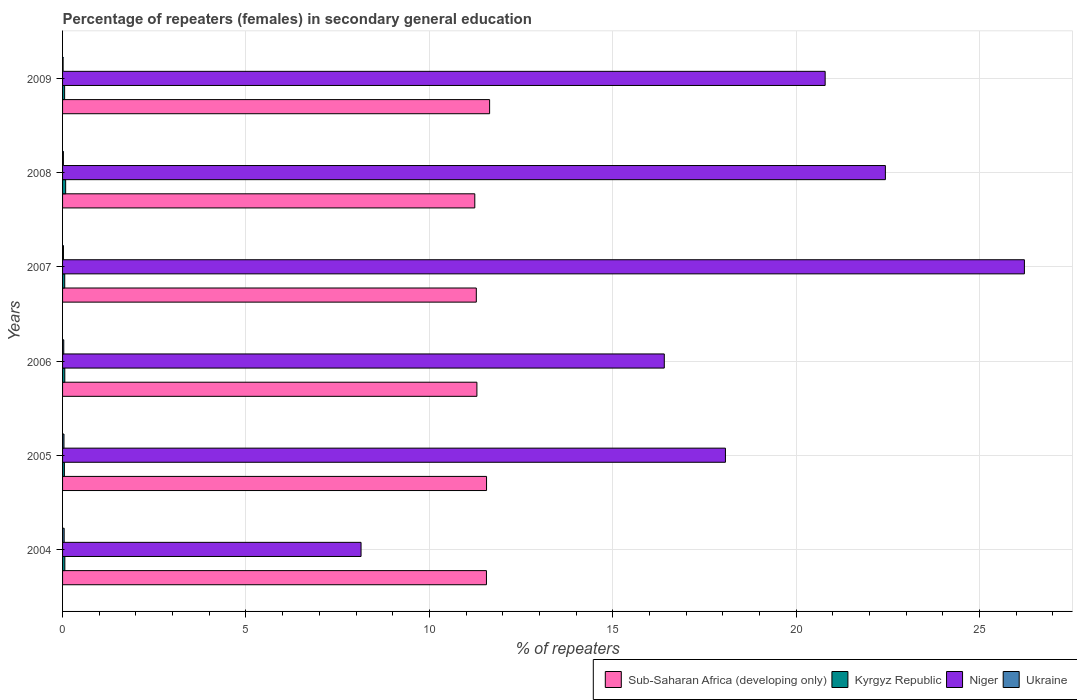How many different coloured bars are there?
Ensure brevity in your answer.  4. Are the number of bars per tick equal to the number of legend labels?
Offer a very short reply. Yes. Are the number of bars on each tick of the Y-axis equal?
Provide a short and direct response. Yes. What is the label of the 2nd group of bars from the top?
Your answer should be very brief. 2008. In how many cases, is the number of bars for a given year not equal to the number of legend labels?
Provide a short and direct response. 0. What is the percentage of female repeaters in Niger in 2004?
Offer a terse response. 8.14. Across all years, what is the maximum percentage of female repeaters in Niger?
Make the answer very short. 26.22. Across all years, what is the minimum percentage of female repeaters in Niger?
Offer a very short reply. 8.14. In which year was the percentage of female repeaters in Niger maximum?
Provide a short and direct response. 2007. What is the total percentage of female repeaters in Sub-Saharan Africa (developing only) in the graph?
Offer a terse response. 68.57. What is the difference between the percentage of female repeaters in Niger in 2004 and that in 2007?
Give a very brief answer. -18.09. What is the difference between the percentage of female repeaters in Niger in 2009 and the percentage of female repeaters in Ukraine in 2007?
Your answer should be very brief. 20.77. What is the average percentage of female repeaters in Sub-Saharan Africa (developing only) per year?
Ensure brevity in your answer.  11.43. In the year 2007, what is the difference between the percentage of female repeaters in Niger and percentage of female repeaters in Sub-Saharan Africa (developing only)?
Make the answer very short. 14.94. In how many years, is the percentage of female repeaters in Kyrgyz Republic greater than 14 %?
Your response must be concise. 0. What is the ratio of the percentage of female repeaters in Ukraine in 2005 to that in 2009?
Keep it short and to the point. 2.65. Is the difference between the percentage of female repeaters in Niger in 2007 and 2008 greater than the difference between the percentage of female repeaters in Sub-Saharan Africa (developing only) in 2007 and 2008?
Provide a succinct answer. Yes. What is the difference between the highest and the second highest percentage of female repeaters in Kyrgyz Republic?
Provide a succinct answer. 0.02. What is the difference between the highest and the lowest percentage of female repeaters in Sub-Saharan Africa (developing only)?
Your response must be concise. 0.4. Is the sum of the percentage of female repeaters in Niger in 2007 and 2009 greater than the maximum percentage of female repeaters in Sub-Saharan Africa (developing only) across all years?
Ensure brevity in your answer.  Yes. What does the 1st bar from the top in 2007 represents?
Keep it short and to the point. Ukraine. What does the 3rd bar from the bottom in 2007 represents?
Offer a terse response. Niger. Is it the case that in every year, the sum of the percentage of female repeaters in Niger and percentage of female repeaters in Sub-Saharan Africa (developing only) is greater than the percentage of female repeaters in Kyrgyz Republic?
Your response must be concise. Yes. Does the graph contain grids?
Ensure brevity in your answer.  Yes. Where does the legend appear in the graph?
Your response must be concise. Bottom right. What is the title of the graph?
Provide a succinct answer. Percentage of repeaters (females) in secondary general education. Does "Dominican Republic" appear as one of the legend labels in the graph?
Make the answer very short. No. What is the label or title of the X-axis?
Offer a very short reply. % of repeaters. What is the % of repeaters of Sub-Saharan Africa (developing only) in 2004?
Offer a terse response. 11.56. What is the % of repeaters of Kyrgyz Republic in 2004?
Your answer should be compact. 0.06. What is the % of repeaters of Niger in 2004?
Provide a succinct answer. 8.14. What is the % of repeaters in Ukraine in 2004?
Ensure brevity in your answer.  0.04. What is the % of repeaters in Sub-Saharan Africa (developing only) in 2005?
Give a very brief answer. 11.56. What is the % of repeaters of Kyrgyz Republic in 2005?
Your answer should be very brief. 0.05. What is the % of repeaters in Niger in 2005?
Make the answer very short. 18.07. What is the % of repeaters in Ukraine in 2005?
Keep it short and to the point. 0.04. What is the % of repeaters of Sub-Saharan Africa (developing only) in 2006?
Provide a succinct answer. 11.3. What is the % of repeaters of Kyrgyz Republic in 2006?
Keep it short and to the point. 0.06. What is the % of repeaters in Niger in 2006?
Give a very brief answer. 16.41. What is the % of repeaters in Ukraine in 2006?
Provide a short and direct response. 0.03. What is the % of repeaters of Sub-Saharan Africa (developing only) in 2007?
Keep it short and to the point. 11.28. What is the % of repeaters of Kyrgyz Republic in 2007?
Your response must be concise. 0.06. What is the % of repeaters in Niger in 2007?
Make the answer very short. 26.22. What is the % of repeaters of Ukraine in 2007?
Your answer should be compact. 0.02. What is the % of repeaters of Sub-Saharan Africa (developing only) in 2008?
Keep it short and to the point. 11.24. What is the % of repeaters in Kyrgyz Republic in 2008?
Offer a very short reply. 0.08. What is the % of repeaters of Niger in 2008?
Your answer should be compact. 22.43. What is the % of repeaters of Ukraine in 2008?
Keep it short and to the point. 0.02. What is the % of repeaters in Sub-Saharan Africa (developing only) in 2009?
Offer a very short reply. 11.64. What is the % of repeaters in Kyrgyz Republic in 2009?
Ensure brevity in your answer.  0.06. What is the % of repeaters of Niger in 2009?
Offer a terse response. 20.79. What is the % of repeaters of Ukraine in 2009?
Make the answer very short. 0.01. Across all years, what is the maximum % of repeaters of Sub-Saharan Africa (developing only)?
Give a very brief answer. 11.64. Across all years, what is the maximum % of repeaters in Kyrgyz Republic?
Provide a short and direct response. 0.08. Across all years, what is the maximum % of repeaters of Niger?
Your answer should be very brief. 26.22. Across all years, what is the maximum % of repeaters in Ukraine?
Keep it short and to the point. 0.04. Across all years, what is the minimum % of repeaters in Sub-Saharan Africa (developing only)?
Provide a succinct answer. 11.24. Across all years, what is the minimum % of repeaters in Kyrgyz Republic?
Make the answer very short. 0.05. Across all years, what is the minimum % of repeaters in Niger?
Keep it short and to the point. 8.14. Across all years, what is the minimum % of repeaters of Ukraine?
Make the answer very short. 0.01. What is the total % of repeaters of Sub-Saharan Africa (developing only) in the graph?
Ensure brevity in your answer.  68.57. What is the total % of repeaters of Kyrgyz Republic in the graph?
Make the answer very short. 0.37. What is the total % of repeaters of Niger in the graph?
Your answer should be very brief. 112.06. What is the total % of repeaters in Ukraine in the graph?
Keep it short and to the point. 0.18. What is the difference between the % of repeaters of Sub-Saharan Africa (developing only) in 2004 and that in 2005?
Your answer should be compact. -0. What is the difference between the % of repeaters in Kyrgyz Republic in 2004 and that in 2005?
Provide a short and direct response. 0.01. What is the difference between the % of repeaters of Niger in 2004 and that in 2005?
Provide a succinct answer. -9.93. What is the difference between the % of repeaters of Ukraine in 2004 and that in 2005?
Keep it short and to the point. 0. What is the difference between the % of repeaters of Sub-Saharan Africa (developing only) in 2004 and that in 2006?
Provide a succinct answer. 0.26. What is the difference between the % of repeaters in Kyrgyz Republic in 2004 and that in 2006?
Ensure brevity in your answer.  0. What is the difference between the % of repeaters of Niger in 2004 and that in 2006?
Keep it short and to the point. -8.27. What is the difference between the % of repeaters of Ukraine in 2004 and that in 2006?
Offer a very short reply. 0.01. What is the difference between the % of repeaters of Sub-Saharan Africa (developing only) in 2004 and that in 2007?
Provide a short and direct response. 0.28. What is the difference between the % of repeaters of Kyrgyz Republic in 2004 and that in 2007?
Your answer should be compact. 0. What is the difference between the % of repeaters in Niger in 2004 and that in 2007?
Provide a short and direct response. -18.09. What is the difference between the % of repeaters in Ukraine in 2004 and that in 2007?
Offer a very short reply. 0.02. What is the difference between the % of repeaters in Sub-Saharan Africa (developing only) in 2004 and that in 2008?
Your answer should be very brief. 0.32. What is the difference between the % of repeaters of Kyrgyz Republic in 2004 and that in 2008?
Your answer should be compact. -0.02. What is the difference between the % of repeaters in Niger in 2004 and that in 2008?
Your answer should be compact. -14.3. What is the difference between the % of repeaters of Ukraine in 2004 and that in 2008?
Offer a terse response. 0.02. What is the difference between the % of repeaters in Sub-Saharan Africa (developing only) in 2004 and that in 2009?
Provide a succinct answer. -0.09. What is the difference between the % of repeaters in Kyrgyz Republic in 2004 and that in 2009?
Your response must be concise. 0.01. What is the difference between the % of repeaters of Niger in 2004 and that in 2009?
Ensure brevity in your answer.  -12.65. What is the difference between the % of repeaters in Ukraine in 2004 and that in 2009?
Provide a short and direct response. 0.03. What is the difference between the % of repeaters of Sub-Saharan Africa (developing only) in 2005 and that in 2006?
Ensure brevity in your answer.  0.26. What is the difference between the % of repeaters in Kyrgyz Republic in 2005 and that in 2006?
Your response must be concise. -0.01. What is the difference between the % of repeaters of Niger in 2005 and that in 2006?
Keep it short and to the point. 1.67. What is the difference between the % of repeaters of Ukraine in 2005 and that in 2006?
Your response must be concise. 0.01. What is the difference between the % of repeaters in Sub-Saharan Africa (developing only) in 2005 and that in 2007?
Give a very brief answer. 0.28. What is the difference between the % of repeaters of Kyrgyz Republic in 2005 and that in 2007?
Offer a very short reply. -0.01. What is the difference between the % of repeaters in Niger in 2005 and that in 2007?
Your answer should be very brief. -8.15. What is the difference between the % of repeaters of Ukraine in 2005 and that in 2007?
Give a very brief answer. 0.01. What is the difference between the % of repeaters in Sub-Saharan Africa (developing only) in 2005 and that in 2008?
Offer a very short reply. 0.32. What is the difference between the % of repeaters of Kyrgyz Republic in 2005 and that in 2008?
Offer a terse response. -0.03. What is the difference between the % of repeaters of Niger in 2005 and that in 2008?
Your answer should be compact. -4.36. What is the difference between the % of repeaters of Ukraine in 2005 and that in 2008?
Your answer should be very brief. 0.02. What is the difference between the % of repeaters of Sub-Saharan Africa (developing only) in 2005 and that in 2009?
Offer a very short reply. -0.08. What is the difference between the % of repeaters in Kyrgyz Republic in 2005 and that in 2009?
Your answer should be very brief. -0.01. What is the difference between the % of repeaters in Niger in 2005 and that in 2009?
Your answer should be compact. -2.72. What is the difference between the % of repeaters in Ukraine in 2005 and that in 2009?
Ensure brevity in your answer.  0.02. What is the difference between the % of repeaters of Sub-Saharan Africa (developing only) in 2006 and that in 2007?
Ensure brevity in your answer.  0.02. What is the difference between the % of repeaters of Kyrgyz Republic in 2006 and that in 2007?
Offer a terse response. 0. What is the difference between the % of repeaters of Niger in 2006 and that in 2007?
Make the answer very short. -9.82. What is the difference between the % of repeaters of Ukraine in 2006 and that in 2007?
Provide a succinct answer. 0.01. What is the difference between the % of repeaters of Sub-Saharan Africa (developing only) in 2006 and that in 2008?
Your answer should be very brief. 0.06. What is the difference between the % of repeaters in Kyrgyz Republic in 2006 and that in 2008?
Provide a succinct answer. -0.02. What is the difference between the % of repeaters in Niger in 2006 and that in 2008?
Your response must be concise. -6.03. What is the difference between the % of repeaters of Ukraine in 2006 and that in 2008?
Offer a terse response. 0.01. What is the difference between the % of repeaters in Sub-Saharan Africa (developing only) in 2006 and that in 2009?
Offer a terse response. -0.35. What is the difference between the % of repeaters in Kyrgyz Republic in 2006 and that in 2009?
Your answer should be compact. 0. What is the difference between the % of repeaters in Niger in 2006 and that in 2009?
Provide a short and direct response. -4.39. What is the difference between the % of repeaters in Ukraine in 2006 and that in 2009?
Provide a succinct answer. 0.02. What is the difference between the % of repeaters of Sub-Saharan Africa (developing only) in 2007 and that in 2008?
Provide a succinct answer. 0.04. What is the difference between the % of repeaters in Kyrgyz Republic in 2007 and that in 2008?
Offer a very short reply. -0.03. What is the difference between the % of repeaters of Niger in 2007 and that in 2008?
Offer a terse response. 3.79. What is the difference between the % of repeaters of Ukraine in 2007 and that in 2008?
Offer a very short reply. 0. What is the difference between the % of repeaters in Sub-Saharan Africa (developing only) in 2007 and that in 2009?
Offer a very short reply. -0.36. What is the difference between the % of repeaters in Kyrgyz Republic in 2007 and that in 2009?
Provide a succinct answer. 0. What is the difference between the % of repeaters in Niger in 2007 and that in 2009?
Give a very brief answer. 5.43. What is the difference between the % of repeaters of Ukraine in 2007 and that in 2009?
Offer a terse response. 0.01. What is the difference between the % of repeaters of Sub-Saharan Africa (developing only) in 2008 and that in 2009?
Offer a very short reply. -0.4. What is the difference between the % of repeaters in Kyrgyz Republic in 2008 and that in 2009?
Make the answer very short. 0.03. What is the difference between the % of repeaters of Niger in 2008 and that in 2009?
Offer a very short reply. 1.64. What is the difference between the % of repeaters of Ukraine in 2008 and that in 2009?
Your response must be concise. 0.01. What is the difference between the % of repeaters in Sub-Saharan Africa (developing only) in 2004 and the % of repeaters in Kyrgyz Republic in 2005?
Provide a short and direct response. 11.51. What is the difference between the % of repeaters in Sub-Saharan Africa (developing only) in 2004 and the % of repeaters in Niger in 2005?
Your answer should be compact. -6.52. What is the difference between the % of repeaters in Sub-Saharan Africa (developing only) in 2004 and the % of repeaters in Ukraine in 2005?
Ensure brevity in your answer.  11.52. What is the difference between the % of repeaters in Kyrgyz Republic in 2004 and the % of repeaters in Niger in 2005?
Provide a short and direct response. -18.01. What is the difference between the % of repeaters of Kyrgyz Republic in 2004 and the % of repeaters of Ukraine in 2005?
Provide a succinct answer. 0.02. What is the difference between the % of repeaters in Niger in 2004 and the % of repeaters in Ukraine in 2005?
Provide a succinct answer. 8.1. What is the difference between the % of repeaters of Sub-Saharan Africa (developing only) in 2004 and the % of repeaters of Kyrgyz Republic in 2006?
Provide a succinct answer. 11.5. What is the difference between the % of repeaters in Sub-Saharan Africa (developing only) in 2004 and the % of repeaters in Niger in 2006?
Ensure brevity in your answer.  -4.85. What is the difference between the % of repeaters in Sub-Saharan Africa (developing only) in 2004 and the % of repeaters in Ukraine in 2006?
Give a very brief answer. 11.52. What is the difference between the % of repeaters of Kyrgyz Republic in 2004 and the % of repeaters of Niger in 2006?
Provide a succinct answer. -16.34. What is the difference between the % of repeaters in Kyrgyz Republic in 2004 and the % of repeaters in Ukraine in 2006?
Offer a terse response. 0.03. What is the difference between the % of repeaters in Niger in 2004 and the % of repeaters in Ukraine in 2006?
Make the answer very short. 8.1. What is the difference between the % of repeaters in Sub-Saharan Africa (developing only) in 2004 and the % of repeaters in Kyrgyz Republic in 2007?
Give a very brief answer. 11.5. What is the difference between the % of repeaters of Sub-Saharan Africa (developing only) in 2004 and the % of repeaters of Niger in 2007?
Provide a short and direct response. -14.67. What is the difference between the % of repeaters of Sub-Saharan Africa (developing only) in 2004 and the % of repeaters of Ukraine in 2007?
Keep it short and to the point. 11.53. What is the difference between the % of repeaters in Kyrgyz Republic in 2004 and the % of repeaters in Niger in 2007?
Offer a very short reply. -26.16. What is the difference between the % of repeaters of Kyrgyz Republic in 2004 and the % of repeaters of Ukraine in 2007?
Your response must be concise. 0.04. What is the difference between the % of repeaters of Niger in 2004 and the % of repeaters of Ukraine in 2007?
Your answer should be very brief. 8.11. What is the difference between the % of repeaters in Sub-Saharan Africa (developing only) in 2004 and the % of repeaters in Kyrgyz Republic in 2008?
Your response must be concise. 11.47. What is the difference between the % of repeaters of Sub-Saharan Africa (developing only) in 2004 and the % of repeaters of Niger in 2008?
Provide a succinct answer. -10.88. What is the difference between the % of repeaters of Sub-Saharan Africa (developing only) in 2004 and the % of repeaters of Ukraine in 2008?
Your response must be concise. 11.53. What is the difference between the % of repeaters of Kyrgyz Republic in 2004 and the % of repeaters of Niger in 2008?
Your answer should be very brief. -22.37. What is the difference between the % of repeaters in Kyrgyz Republic in 2004 and the % of repeaters in Ukraine in 2008?
Your response must be concise. 0.04. What is the difference between the % of repeaters of Niger in 2004 and the % of repeaters of Ukraine in 2008?
Ensure brevity in your answer.  8.11. What is the difference between the % of repeaters in Sub-Saharan Africa (developing only) in 2004 and the % of repeaters in Kyrgyz Republic in 2009?
Offer a terse response. 11.5. What is the difference between the % of repeaters of Sub-Saharan Africa (developing only) in 2004 and the % of repeaters of Niger in 2009?
Offer a terse response. -9.23. What is the difference between the % of repeaters in Sub-Saharan Africa (developing only) in 2004 and the % of repeaters in Ukraine in 2009?
Provide a succinct answer. 11.54. What is the difference between the % of repeaters of Kyrgyz Republic in 2004 and the % of repeaters of Niger in 2009?
Provide a succinct answer. -20.73. What is the difference between the % of repeaters of Kyrgyz Republic in 2004 and the % of repeaters of Ukraine in 2009?
Provide a succinct answer. 0.05. What is the difference between the % of repeaters in Niger in 2004 and the % of repeaters in Ukraine in 2009?
Keep it short and to the point. 8.12. What is the difference between the % of repeaters in Sub-Saharan Africa (developing only) in 2005 and the % of repeaters in Kyrgyz Republic in 2006?
Offer a terse response. 11.5. What is the difference between the % of repeaters of Sub-Saharan Africa (developing only) in 2005 and the % of repeaters of Niger in 2006?
Ensure brevity in your answer.  -4.85. What is the difference between the % of repeaters of Sub-Saharan Africa (developing only) in 2005 and the % of repeaters of Ukraine in 2006?
Give a very brief answer. 11.53. What is the difference between the % of repeaters in Kyrgyz Republic in 2005 and the % of repeaters in Niger in 2006?
Ensure brevity in your answer.  -16.36. What is the difference between the % of repeaters in Kyrgyz Republic in 2005 and the % of repeaters in Ukraine in 2006?
Offer a terse response. 0.02. What is the difference between the % of repeaters of Niger in 2005 and the % of repeaters of Ukraine in 2006?
Offer a terse response. 18.04. What is the difference between the % of repeaters in Sub-Saharan Africa (developing only) in 2005 and the % of repeaters in Kyrgyz Republic in 2007?
Give a very brief answer. 11.5. What is the difference between the % of repeaters in Sub-Saharan Africa (developing only) in 2005 and the % of repeaters in Niger in 2007?
Give a very brief answer. -14.66. What is the difference between the % of repeaters of Sub-Saharan Africa (developing only) in 2005 and the % of repeaters of Ukraine in 2007?
Provide a succinct answer. 11.54. What is the difference between the % of repeaters in Kyrgyz Republic in 2005 and the % of repeaters in Niger in 2007?
Offer a terse response. -26.17. What is the difference between the % of repeaters of Kyrgyz Republic in 2005 and the % of repeaters of Ukraine in 2007?
Make the answer very short. 0.03. What is the difference between the % of repeaters of Niger in 2005 and the % of repeaters of Ukraine in 2007?
Keep it short and to the point. 18.05. What is the difference between the % of repeaters of Sub-Saharan Africa (developing only) in 2005 and the % of repeaters of Kyrgyz Republic in 2008?
Provide a succinct answer. 11.47. What is the difference between the % of repeaters in Sub-Saharan Africa (developing only) in 2005 and the % of repeaters in Niger in 2008?
Your response must be concise. -10.87. What is the difference between the % of repeaters in Sub-Saharan Africa (developing only) in 2005 and the % of repeaters in Ukraine in 2008?
Your response must be concise. 11.54. What is the difference between the % of repeaters of Kyrgyz Republic in 2005 and the % of repeaters of Niger in 2008?
Make the answer very short. -22.38. What is the difference between the % of repeaters in Kyrgyz Republic in 2005 and the % of repeaters in Ukraine in 2008?
Your answer should be very brief. 0.03. What is the difference between the % of repeaters of Niger in 2005 and the % of repeaters of Ukraine in 2008?
Provide a succinct answer. 18.05. What is the difference between the % of repeaters of Sub-Saharan Africa (developing only) in 2005 and the % of repeaters of Kyrgyz Republic in 2009?
Provide a succinct answer. 11.5. What is the difference between the % of repeaters in Sub-Saharan Africa (developing only) in 2005 and the % of repeaters in Niger in 2009?
Keep it short and to the point. -9.23. What is the difference between the % of repeaters of Sub-Saharan Africa (developing only) in 2005 and the % of repeaters of Ukraine in 2009?
Offer a very short reply. 11.54. What is the difference between the % of repeaters of Kyrgyz Republic in 2005 and the % of repeaters of Niger in 2009?
Your answer should be very brief. -20.74. What is the difference between the % of repeaters of Kyrgyz Republic in 2005 and the % of repeaters of Ukraine in 2009?
Your answer should be compact. 0.04. What is the difference between the % of repeaters in Niger in 2005 and the % of repeaters in Ukraine in 2009?
Your answer should be compact. 18.06. What is the difference between the % of repeaters of Sub-Saharan Africa (developing only) in 2006 and the % of repeaters of Kyrgyz Republic in 2007?
Your answer should be compact. 11.24. What is the difference between the % of repeaters of Sub-Saharan Africa (developing only) in 2006 and the % of repeaters of Niger in 2007?
Offer a terse response. -14.93. What is the difference between the % of repeaters of Sub-Saharan Africa (developing only) in 2006 and the % of repeaters of Ukraine in 2007?
Offer a terse response. 11.27. What is the difference between the % of repeaters of Kyrgyz Republic in 2006 and the % of repeaters of Niger in 2007?
Provide a succinct answer. -26.16. What is the difference between the % of repeaters of Kyrgyz Republic in 2006 and the % of repeaters of Ukraine in 2007?
Ensure brevity in your answer.  0.04. What is the difference between the % of repeaters in Niger in 2006 and the % of repeaters in Ukraine in 2007?
Give a very brief answer. 16.38. What is the difference between the % of repeaters in Sub-Saharan Africa (developing only) in 2006 and the % of repeaters in Kyrgyz Republic in 2008?
Offer a terse response. 11.21. What is the difference between the % of repeaters in Sub-Saharan Africa (developing only) in 2006 and the % of repeaters in Niger in 2008?
Provide a succinct answer. -11.14. What is the difference between the % of repeaters of Sub-Saharan Africa (developing only) in 2006 and the % of repeaters of Ukraine in 2008?
Keep it short and to the point. 11.27. What is the difference between the % of repeaters in Kyrgyz Republic in 2006 and the % of repeaters in Niger in 2008?
Offer a very short reply. -22.37. What is the difference between the % of repeaters of Kyrgyz Republic in 2006 and the % of repeaters of Ukraine in 2008?
Provide a short and direct response. 0.04. What is the difference between the % of repeaters of Niger in 2006 and the % of repeaters of Ukraine in 2008?
Ensure brevity in your answer.  16.38. What is the difference between the % of repeaters in Sub-Saharan Africa (developing only) in 2006 and the % of repeaters in Kyrgyz Republic in 2009?
Your answer should be compact. 11.24. What is the difference between the % of repeaters of Sub-Saharan Africa (developing only) in 2006 and the % of repeaters of Niger in 2009?
Offer a terse response. -9.49. What is the difference between the % of repeaters in Sub-Saharan Africa (developing only) in 2006 and the % of repeaters in Ukraine in 2009?
Ensure brevity in your answer.  11.28. What is the difference between the % of repeaters in Kyrgyz Republic in 2006 and the % of repeaters in Niger in 2009?
Your response must be concise. -20.73. What is the difference between the % of repeaters in Kyrgyz Republic in 2006 and the % of repeaters in Ukraine in 2009?
Keep it short and to the point. 0.05. What is the difference between the % of repeaters of Niger in 2006 and the % of repeaters of Ukraine in 2009?
Offer a very short reply. 16.39. What is the difference between the % of repeaters of Sub-Saharan Africa (developing only) in 2007 and the % of repeaters of Kyrgyz Republic in 2008?
Ensure brevity in your answer.  11.2. What is the difference between the % of repeaters of Sub-Saharan Africa (developing only) in 2007 and the % of repeaters of Niger in 2008?
Offer a terse response. -11.15. What is the difference between the % of repeaters of Sub-Saharan Africa (developing only) in 2007 and the % of repeaters of Ukraine in 2008?
Make the answer very short. 11.26. What is the difference between the % of repeaters of Kyrgyz Republic in 2007 and the % of repeaters of Niger in 2008?
Give a very brief answer. -22.37. What is the difference between the % of repeaters in Kyrgyz Republic in 2007 and the % of repeaters in Ukraine in 2008?
Provide a succinct answer. 0.04. What is the difference between the % of repeaters in Niger in 2007 and the % of repeaters in Ukraine in 2008?
Offer a very short reply. 26.2. What is the difference between the % of repeaters in Sub-Saharan Africa (developing only) in 2007 and the % of repeaters in Kyrgyz Republic in 2009?
Ensure brevity in your answer.  11.22. What is the difference between the % of repeaters in Sub-Saharan Africa (developing only) in 2007 and the % of repeaters in Niger in 2009?
Your answer should be compact. -9.51. What is the difference between the % of repeaters in Sub-Saharan Africa (developing only) in 2007 and the % of repeaters in Ukraine in 2009?
Provide a short and direct response. 11.27. What is the difference between the % of repeaters in Kyrgyz Republic in 2007 and the % of repeaters in Niger in 2009?
Ensure brevity in your answer.  -20.73. What is the difference between the % of repeaters in Kyrgyz Republic in 2007 and the % of repeaters in Ukraine in 2009?
Your answer should be compact. 0.04. What is the difference between the % of repeaters in Niger in 2007 and the % of repeaters in Ukraine in 2009?
Keep it short and to the point. 26.21. What is the difference between the % of repeaters in Sub-Saharan Africa (developing only) in 2008 and the % of repeaters in Kyrgyz Republic in 2009?
Offer a very short reply. 11.18. What is the difference between the % of repeaters in Sub-Saharan Africa (developing only) in 2008 and the % of repeaters in Niger in 2009?
Offer a terse response. -9.55. What is the difference between the % of repeaters of Sub-Saharan Africa (developing only) in 2008 and the % of repeaters of Ukraine in 2009?
Give a very brief answer. 11.22. What is the difference between the % of repeaters in Kyrgyz Republic in 2008 and the % of repeaters in Niger in 2009?
Your answer should be compact. -20.71. What is the difference between the % of repeaters of Kyrgyz Republic in 2008 and the % of repeaters of Ukraine in 2009?
Offer a very short reply. 0.07. What is the difference between the % of repeaters of Niger in 2008 and the % of repeaters of Ukraine in 2009?
Provide a short and direct response. 22.42. What is the average % of repeaters of Sub-Saharan Africa (developing only) per year?
Offer a very short reply. 11.43. What is the average % of repeaters in Kyrgyz Republic per year?
Make the answer very short. 0.06. What is the average % of repeaters in Niger per year?
Keep it short and to the point. 18.68. What is the average % of repeaters in Ukraine per year?
Offer a terse response. 0.03. In the year 2004, what is the difference between the % of repeaters in Sub-Saharan Africa (developing only) and % of repeaters in Kyrgyz Republic?
Offer a very short reply. 11.49. In the year 2004, what is the difference between the % of repeaters in Sub-Saharan Africa (developing only) and % of repeaters in Niger?
Provide a succinct answer. 3.42. In the year 2004, what is the difference between the % of repeaters in Sub-Saharan Africa (developing only) and % of repeaters in Ukraine?
Your response must be concise. 11.51. In the year 2004, what is the difference between the % of repeaters of Kyrgyz Republic and % of repeaters of Niger?
Keep it short and to the point. -8.08. In the year 2004, what is the difference between the % of repeaters of Kyrgyz Republic and % of repeaters of Ukraine?
Your answer should be very brief. 0.02. In the year 2004, what is the difference between the % of repeaters of Niger and % of repeaters of Ukraine?
Ensure brevity in your answer.  8.09. In the year 2005, what is the difference between the % of repeaters in Sub-Saharan Africa (developing only) and % of repeaters in Kyrgyz Republic?
Offer a very short reply. 11.51. In the year 2005, what is the difference between the % of repeaters in Sub-Saharan Africa (developing only) and % of repeaters in Niger?
Your answer should be compact. -6.51. In the year 2005, what is the difference between the % of repeaters of Sub-Saharan Africa (developing only) and % of repeaters of Ukraine?
Your answer should be very brief. 11.52. In the year 2005, what is the difference between the % of repeaters in Kyrgyz Republic and % of repeaters in Niger?
Give a very brief answer. -18.02. In the year 2005, what is the difference between the % of repeaters in Kyrgyz Republic and % of repeaters in Ukraine?
Make the answer very short. 0.01. In the year 2005, what is the difference between the % of repeaters in Niger and % of repeaters in Ukraine?
Ensure brevity in your answer.  18.03. In the year 2006, what is the difference between the % of repeaters of Sub-Saharan Africa (developing only) and % of repeaters of Kyrgyz Republic?
Offer a terse response. 11.24. In the year 2006, what is the difference between the % of repeaters in Sub-Saharan Africa (developing only) and % of repeaters in Niger?
Make the answer very short. -5.11. In the year 2006, what is the difference between the % of repeaters in Sub-Saharan Africa (developing only) and % of repeaters in Ukraine?
Your answer should be very brief. 11.26. In the year 2006, what is the difference between the % of repeaters in Kyrgyz Republic and % of repeaters in Niger?
Offer a very short reply. -16.34. In the year 2006, what is the difference between the % of repeaters in Kyrgyz Republic and % of repeaters in Ukraine?
Your answer should be very brief. 0.03. In the year 2006, what is the difference between the % of repeaters of Niger and % of repeaters of Ukraine?
Give a very brief answer. 16.37. In the year 2007, what is the difference between the % of repeaters of Sub-Saharan Africa (developing only) and % of repeaters of Kyrgyz Republic?
Offer a very short reply. 11.22. In the year 2007, what is the difference between the % of repeaters in Sub-Saharan Africa (developing only) and % of repeaters in Niger?
Your answer should be very brief. -14.94. In the year 2007, what is the difference between the % of repeaters of Sub-Saharan Africa (developing only) and % of repeaters of Ukraine?
Your answer should be compact. 11.26. In the year 2007, what is the difference between the % of repeaters in Kyrgyz Republic and % of repeaters in Niger?
Your response must be concise. -26.16. In the year 2007, what is the difference between the % of repeaters of Kyrgyz Republic and % of repeaters of Ukraine?
Offer a very short reply. 0.04. In the year 2007, what is the difference between the % of repeaters in Niger and % of repeaters in Ukraine?
Your answer should be very brief. 26.2. In the year 2008, what is the difference between the % of repeaters of Sub-Saharan Africa (developing only) and % of repeaters of Kyrgyz Republic?
Offer a very short reply. 11.15. In the year 2008, what is the difference between the % of repeaters of Sub-Saharan Africa (developing only) and % of repeaters of Niger?
Ensure brevity in your answer.  -11.19. In the year 2008, what is the difference between the % of repeaters in Sub-Saharan Africa (developing only) and % of repeaters in Ukraine?
Your answer should be very brief. 11.22. In the year 2008, what is the difference between the % of repeaters in Kyrgyz Republic and % of repeaters in Niger?
Make the answer very short. -22.35. In the year 2008, what is the difference between the % of repeaters of Kyrgyz Republic and % of repeaters of Ukraine?
Your response must be concise. 0.06. In the year 2008, what is the difference between the % of repeaters in Niger and % of repeaters in Ukraine?
Provide a succinct answer. 22.41. In the year 2009, what is the difference between the % of repeaters of Sub-Saharan Africa (developing only) and % of repeaters of Kyrgyz Republic?
Give a very brief answer. 11.59. In the year 2009, what is the difference between the % of repeaters of Sub-Saharan Africa (developing only) and % of repeaters of Niger?
Offer a terse response. -9.15. In the year 2009, what is the difference between the % of repeaters of Sub-Saharan Africa (developing only) and % of repeaters of Ukraine?
Provide a succinct answer. 11.63. In the year 2009, what is the difference between the % of repeaters of Kyrgyz Republic and % of repeaters of Niger?
Provide a short and direct response. -20.73. In the year 2009, what is the difference between the % of repeaters in Kyrgyz Republic and % of repeaters in Ukraine?
Provide a succinct answer. 0.04. In the year 2009, what is the difference between the % of repeaters of Niger and % of repeaters of Ukraine?
Provide a short and direct response. 20.78. What is the ratio of the % of repeaters of Kyrgyz Republic in 2004 to that in 2005?
Give a very brief answer. 1.24. What is the ratio of the % of repeaters in Niger in 2004 to that in 2005?
Ensure brevity in your answer.  0.45. What is the ratio of the % of repeaters of Ukraine in 2004 to that in 2005?
Your answer should be compact. 1.12. What is the ratio of the % of repeaters in Sub-Saharan Africa (developing only) in 2004 to that in 2006?
Your response must be concise. 1.02. What is the ratio of the % of repeaters in Kyrgyz Republic in 2004 to that in 2006?
Your answer should be very brief. 1.02. What is the ratio of the % of repeaters of Niger in 2004 to that in 2006?
Offer a terse response. 0.5. What is the ratio of the % of repeaters in Ukraine in 2004 to that in 2006?
Your response must be concise. 1.33. What is the ratio of the % of repeaters in Sub-Saharan Africa (developing only) in 2004 to that in 2007?
Keep it short and to the point. 1.02. What is the ratio of the % of repeaters in Kyrgyz Republic in 2004 to that in 2007?
Offer a terse response. 1.05. What is the ratio of the % of repeaters of Niger in 2004 to that in 2007?
Ensure brevity in your answer.  0.31. What is the ratio of the % of repeaters in Ukraine in 2004 to that in 2007?
Your response must be concise. 1.8. What is the ratio of the % of repeaters in Sub-Saharan Africa (developing only) in 2004 to that in 2008?
Offer a very short reply. 1.03. What is the ratio of the % of repeaters in Kyrgyz Republic in 2004 to that in 2008?
Offer a very short reply. 0.73. What is the ratio of the % of repeaters in Niger in 2004 to that in 2008?
Ensure brevity in your answer.  0.36. What is the ratio of the % of repeaters in Ukraine in 2004 to that in 2008?
Provide a short and direct response. 1.92. What is the ratio of the % of repeaters of Sub-Saharan Africa (developing only) in 2004 to that in 2009?
Provide a succinct answer. 0.99. What is the ratio of the % of repeaters of Kyrgyz Republic in 2004 to that in 2009?
Offer a very short reply. 1.11. What is the ratio of the % of repeaters of Niger in 2004 to that in 2009?
Provide a short and direct response. 0.39. What is the ratio of the % of repeaters of Ukraine in 2004 to that in 2009?
Make the answer very short. 2.96. What is the ratio of the % of repeaters in Sub-Saharan Africa (developing only) in 2005 to that in 2006?
Offer a very short reply. 1.02. What is the ratio of the % of repeaters of Kyrgyz Republic in 2005 to that in 2006?
Offer a terse response. 0.82. What is the ratio of the % of repeaters of Niger in 2005 to that in 2006?
Give a very brief answer. 1.1. What is the ratio of the % of repeaters in Ukraine in 2005 to that in 2006?
Provide a short and direct response. 1.19. What is the ratio of the % of repeaters in Sub-Saharan Africa (developing only) in 2005 to that in 2007?
Make the answer very short. 1.02. What is the ratio of the % of repeaters of Kyrgyz Republic in 2005 to that in 2007?
Provide a short and direct response. 0.84. What is the ratio of the % of repeaters of Niger in 2005 to that in 2007?
Keep it short and to the point. 0.69. What is the ratio of the % of repeaters of Ukraine in 2005 to that in 2007?
Keep it short and to the point. 1.61. What is the ratio of the % of repeaters in Sub-Saharan Africa (developing only) in 2005 to that in 2008?
Make the answer very short. 1.03. What is the ratio of the % of repeaters of Kyrgyz Republic in 2005 to that in 2008?
Your response must be concise. 0.59. What is the ratio of the % of repeaters of Niger in 2005 to that in 2008?
Provide a short and direct response. 0.81. What is the ratio of the % of repeaters in Ukraine in 2005 to that in 2008?
Give a very brief answer. 1.71. What is the ratio of the % of repeaters in Kyrgyz Republic in 2005 to that in 2009?
Make the answer very short. 0.89. What is the ratio of the % of repeaters of Niger in 2005 to that in 2009?
Keep it short and to the point. 0.87. What is the ratio of the % of repeaters in Ukraine in 2005 to that in 2009?
Ensure brevity in your answer.  2.65. What is the ratio of the % of repeaters of Kyrgyz Republic in 2006 to that in 2007?
Offer a very short reply. 1.03. What is the ratio of the % of repeaters in Niger in 2006 to that in 2007?
Offer a very short reply. 0.63. What is the ratio of the % of repeaters of Ukraine in 2006 to that in 2007?
Keep it short and to the point. 1.36. What is the ratio of the % of repeaters in Kyrgyz Republic in 2006 to that in 2008?
Your answer should be compact. 0.72. What is the ratio of the % of repeaters in Niger in 2006 to that in 2008?
Give a very brief answer. 0.73. What is the ratio of the % of repeaters in Ukraine in 2006 to that in 2008?
Offer a terse response. 1.45. What is the ratio of the % of repeaters in Sub-Saharan Africa (developing only) in 2006 to that in 2009?
Your answer should be very brief. 0.97. What is the ratio of the % of repeaters of Kyrgyz Republic in 2006 to that in 2009?
Offer a very short reply. 1.08. What is the ratio of the % of repeaters of Niger in 2006 to that in 2009?
Keep it short and to the point. 0.79. What is the ratio of the % of repeaters of Ukraine in 2006 to that in 2009?
Provide a short and direct response. 2.24. What is the ratio of the % of repeaters of Sub-Saharan Africa (developing only) in 2007 to that in 2008?
Offer a terse response. 1. What is the ratio of the % of repeaters of Kyrgyz Republic in 2007 to that in 2008?
Your answer should be compact. 0.7. What is the ratio of the % of repeaters of Niger in 2007 to that in 2008?
Give a very brief answer. 1.17. What is the ratio of the % of repeaters of Ukraine in 2007 to that in 2008?
Your answer should be compact. 1.07. What is the ratio of the % of repeaters in Sub-Saharan Africa (developing only) in 2007 to that in 2009?
Your answer should be very brief. 0.97. What is the ratio of the % of repeaters in Kyrgyz Republic in 2007 to that in 2009?
Ensure brevity in your answer.  1.05. What is the ratio of the % of repeaters in Niger in 2007 to that in 2009?
Keep it short and to the point. 1.26. What is the ratio of the % of repeaters in Ukraine in 2007 to that in 2009?
Ensure brevity in your answer.  1.65. What is the ratio of the % of repeaters of Sub-Saharan Africa (developing only) in 2008 to that in 2009?
Make the answer very short. 0.97. What is the ratio of the % of repeaters in Kyrgyz Republic in 2008 to that in 2009?
Ensure brevity in your answer.  1.51. What is the ratio of the % of repeaters in Niger in 2008 to that in 2009?
Offer a terse response. 1.08. What is the ratio of the % of repeaters in Ukraine in 2008 to that in 2009?
Provide a succinct answer. 1.55. What is the difference between the highest and the second highest % of repeaters in Sub-Saharan Africa (developing only)?
Provide a short and direct response. 0.08. What is the difference between the highest and the second highest % of repeaters in Kyrgyz Republic?
Offer a terse response. 0.02. What is the difference between the highest and the second highest % of repeaters of Niger?
Offer a terse response. 3.79. What is the difference between the highest and the second highest % of repeaters of Ukraine?
Provide a succinct answer. 0. What is the difference between the highest and the lowest % of repeaters of Sub-Saharan Africa (developing only)?
Offer a very short reply. 0.4. What is the difference between the highest and the lowest % of repeaters in Kyrgyz Republic?
Your answer should be compact. 0.03. What is the difference between the highest and the lowest % of repeaters in Niger?
Ensure brevity in your answer.  18.09. What is the difference between the highest and the lowest % of repeaters in Ukraine?
Offer a very short reply. 0.03. 